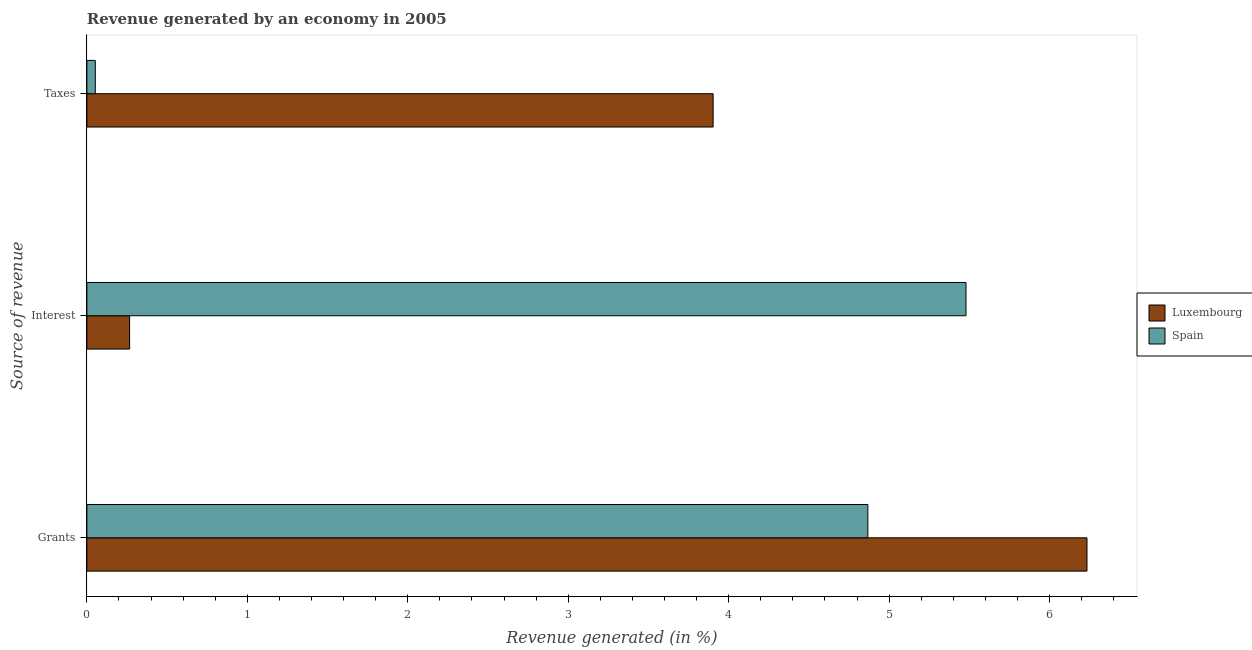How many groups of bars are there?
Offer a very short reply. 3. Are the number of bars on each tick of the Y-axis equal?
Provide a succinct answer. Yes. What is the label of the 3rd group of bars from the top?
Make the answer very short. Grants. What is the percentage of revenue generated by interest in Luxembourg?
Your answer should be very brief. 0.27. Across all countries, what is the maximum percentage of revenue generated by taxes?
Provide a succinct answer. 3.9. Across all countries, what is the minimum percentage of revenue generated by grants?
Keep it short and to the point. 4.87. In which country was the percentage of revenue generated by interest maximum?
Your answer should be compact. Spain. In which country was the percentage of revenue generated by grants minimum?
Keep it short and to the point. Spain. What is the total percentage of revenue generated by taxes in the graph?
Offer a terse response. 3.96. What is the difference between the percentage of revenue generated by taxes in Luxembourg and that in Spain?
Your response must be concise. 3.85. What is the difference between the percentage of revenue generated by grants in Luxembourg and the percentage of revenue generated by interest in Spain?
Keep it short and to the point. 0.75. What is the average percentage of revenue generated by grants per country?
Offer a very short reply. 5.55. What is the difference between the percentage of revenue generated by grants and percentage of revenue generated by taxes in Luxembourg?
Offer a terse response. 2.33. What is the ratio of the percentage of revenue generated by grants in Spain to that in Luxembourg?
Give a very brief answer. 0.78. Is the percentage of revenue generated by interest in Luxembourg less than that in Spain?
Provide a short and direct response. Yes. Is the difference between the percentage of revenue generated by interest in Spain and Luxembourg greater than the difference between the percentage of revenue generated by taxes in Spain and Luxembourg?
Offer a very short reply. Yes. What is the difference between the highest and the second highest percentage of revenue generated by grants?
Give a very brief answer. 1.37. What is the difference between the highest and the lowest percentage of revenue generated by interest?
Ensure brevity in your answer.  5.21. Is the sum of the percentage of revenue generated by interest in Luxembourg and Spain greater than the maximum percentage of revenue generated by taxes across all countries?
Offer a very short reply. Yes. What does the 2nd bar from the bottom in Grants represents?
Your response must be concise. Spain. How many countries are there in the graph?
Offer a terse response. 2. What is the difference between two consecutive major ticks on the X-axis?
Make the answer very short. 1. Are the values on the major ticks of X-axis written in scientific E-notation?
Your answer should be compact. No. Does the graph contain any zero values?
Provide a succinct answer. No. Where does the legend appear in the graph?
Ensure brevity in your answer.  Center right. How many legend labels are there?
Provide a succinct answer. 2. What is the title of the graph?
Provide a succinct answer. Revenue generated by an economy in 2005. Does "Lesotho" appear as one of the legend labels in the graph?
Make the answer very short. No. What is the label or title of the X-axis?
Your response must be concise. Revenue generated (in %). What is the label or title of the Y-axis?
Provide a short and direct response. Source of revenue. What is the Revenue generated (in %) of Luxembourg in Grants?
Make the answer very short. 6.23. What is the Revenue generated (in %) in Spain in Grants?
Your answer should be compact. 4.87. What is the Revenue generated (in %) of Luxembourg in Interest?
Keep it short and to the point. 0.27. What is the Revenue generated (in %) of Spain in Interest?
Ensure brevity in your answer.  5.48. What is the Revenue generated (in %) of Luxembourg in Taxes?
Ensure brevity in your answer.  3.9. What is the Revenue generated (in %) of Spain in Taxes?
Provide a succinct answer. 0.05. Across all Source of revenue, what is the maximum Revenue generated (in %) of Luxembourg?
Your answer should be very brief. 6.23. Across all Source of revenue, what is the maximum Revenue generated (in %) in Spain?
Your response must be concise. 5.48. Across all Source of revenue, what is the minimum Revenue generated (in %) of Luxembourg?
Provide a short and direct response. 0.27. Across all Source of revenue, what is the minimum Revenue generated (in %) of Spain?
Your answer should be very brief. 0.05. What is the total Revenue generated (in %) in Luxembourg in the graph?
Provide a short and direct response. 10.4. What is the total Revenue generated (in %) in Spain in the graph?
Ensure brevity in your answer.  10.4. What is the difference between the Revenue generated (in %) in Luxembourg in Grants and that in Interest?
Ensure brevity in your answer.  5.97. What is the difference between the Revenue generated (in %) of Spain in Grants and that in Interest?
Ensure brevity in your answer.  -0.61. What is the difference between the Revenue generated (in %) in Luxembourg in Grants and that in Taxes?
Offer a terse response. 2.33. What is the difference between the Revenue generated (in %) of Spain in Grants and that in Taxes?
Offer a very short reply. 4.81. What is the difference between the Revenue generated (in %) of Luxembourg in Interest and that in Taxes?
Provide a short and direct response. -3.64. What is the difference between the Revenue generated (in %) in Spain in Interest and that in Taxes?
Provide a short and direct response. 5.43. What is the difference between the Revenue generated (in %) in Luxembourg in Grants and the Revenue generated (in %) in Spain in Interest?
Offer a terse response. 0.75. What is the difference between the Revenue generated (in %) of Luxembourg in Grants and the Revenue generated (in %) of Spain in Taxes?
Your answer should be very brief. 6.18. What is the difference between the Revenue generated (in %) in Luxembourg in Interest and the Revenue generated (in %) in Spain in Taxes?
Provide a short and direct response. 0.21. What is the average Revenue generated (in %) in Luxembourg per Source of revenue?
Ensure brevity in your answer.  3.47. What is the average Revenue generated (in %) in Spain per Source of revenue?
Your answer should be very brief. 3.47. What is the difference between the Revenue generated (in %) in Luxembourg and Revenue generated (in %) in Spain in Grants?
Your answer should be compact. 1.37. What is the difference between the Revenue generated (in %) in Luxembourg and Revenue generated (in %) in Spain in Interest?
Make the answer very short. -5.21. What is the difference between the Revenue generated (in %) in Luxembourg and Revenue generated (in %) in Spain in Taxes?
Make the answer very short. 3.85. What is the ratio of the Revenue generated (in %) in Luxembourg in Grants to that in Interest?
Provide a short and direct response. 23.4. What is the ratio of the Revenue generated (in %) of Spain in Grants to that in Interest?
Make the answer very short. 0.89. What is the ratio of the Revenue generated (in %) of Luxembourg in Grants to that in Taxes?
Offer a very short reply. 1.6. What is the ratio of the Revenue generated (in %) of Spain in Grants to that in Taxes?
Offer a terse response. 92.81. What is the ratio of the Revenue generated (in %) in Luxembourg in Interest to that in Taxes?
Your answer should be compact. 0.07. What is the ratio of the Revenue generated (in %) of Spain in Interest to that in Taxes?
Offer a terse response. 104.48. What is the difference between the highest and the second highest Revenue generated (in %) in Luxembourg?
Offer a terse response. 2.33. What is the difference between the highest and the second highest Revenue generated (in %) in Spain?
Ensure brevity in your answer.  0.61. What is the difference between the highest and the lowest Revenue generated (in %) of Luxembourg?
Your answer should be very brief. 5.97. What is the difference between the highest and the lowest Revenue generated (in %) of Spain?
Offer a terse response. 5.43. 